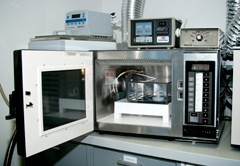Describe the objects in this image and their specific colors. I can see microwave in darkgray, lightgray, black, and gray tones and microwave in darkgray, black, and gray tones in this image. 